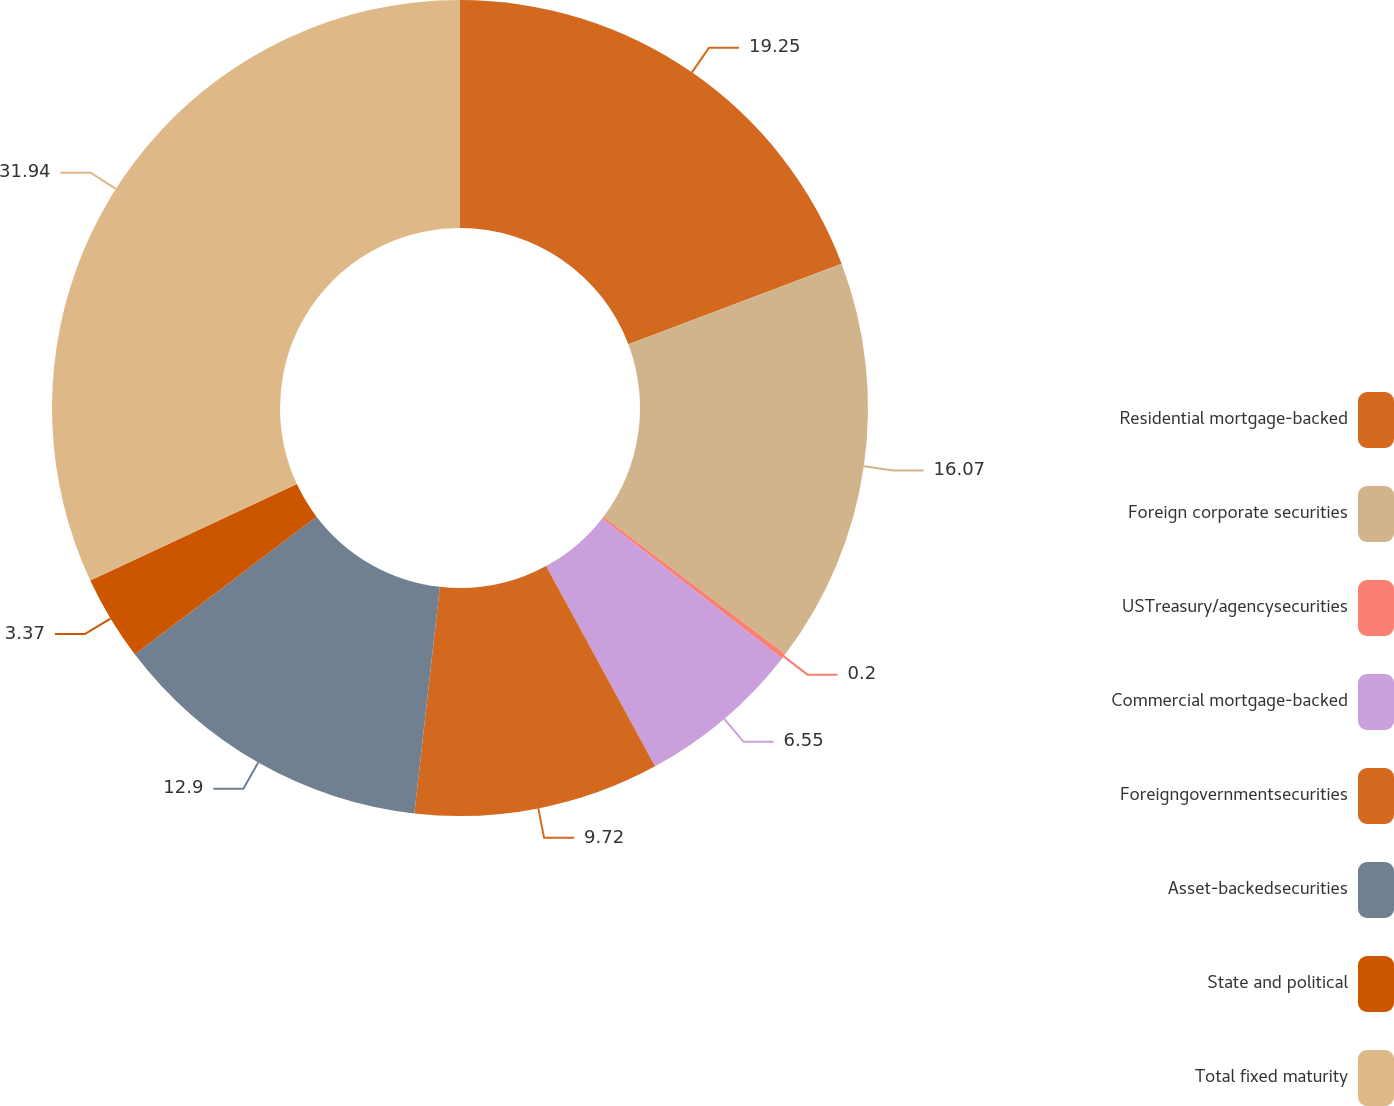Convert chart to OTSL. <chart><loc_0><loc_0><loc_500><loc_500><pie_chart><fcel>Residential mortgage-backed<fcel>Foreign corporate securities<fcel>USTreasury/agencysecurities<fcel>Commercial mortgage-backed<fcel>Foreigngovernmentsecurities<fcel>Asset-backedsecurities<fcel>State and political<fcel>Total fixed maturity<nl><fcel>19.25%<fcel>16.07%<fcel>0.2%<fcel>6.55%<fcel>9.72%<fcel>12.9%<fcel>3.37%<fcel>31.95%<nl></chart> 